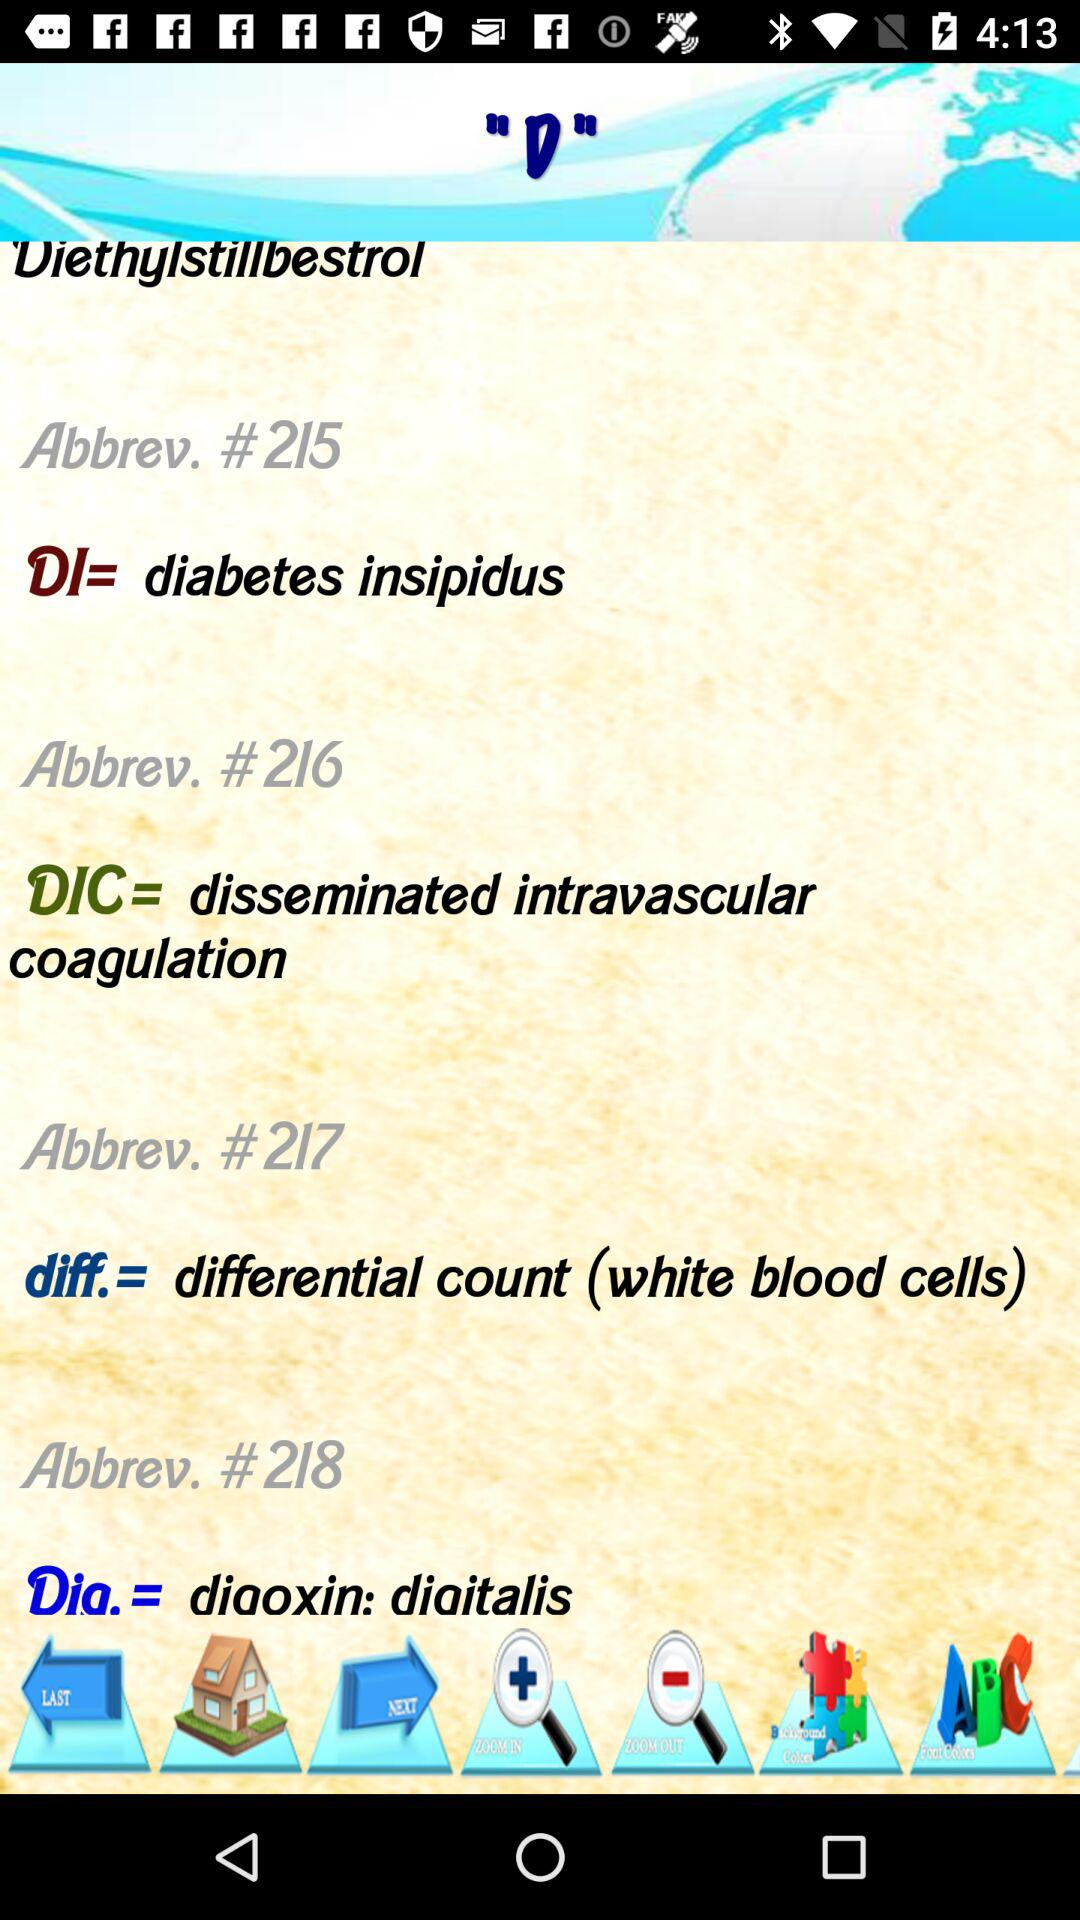What is the abbreviation of number #218? The abbreviation is "Dia.". 